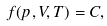<formula> <loc_0><loc_0><loc_500><loc_500>f ( p , V , T ) = C ,</formula> 